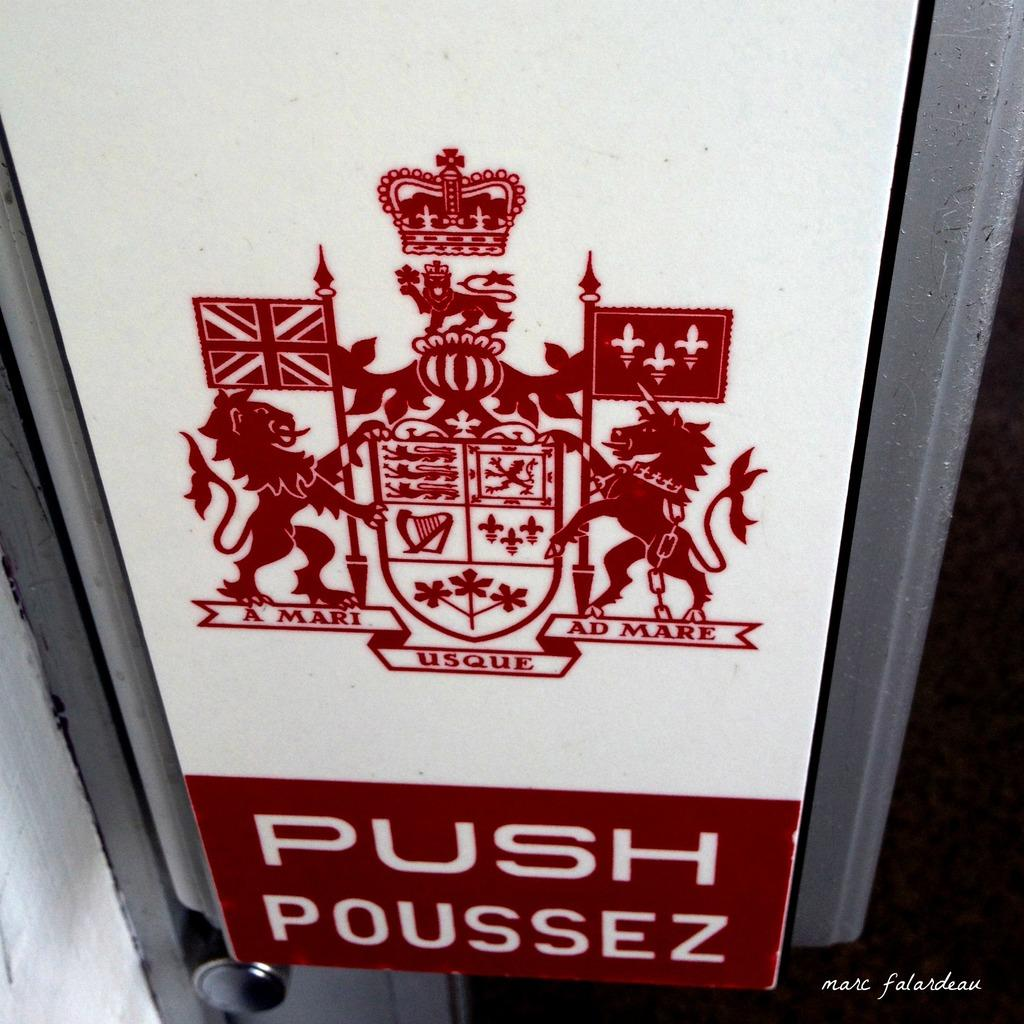Provide a one-sentence caption for the provided image. A sign with latin words A Mari Usque Ad Mare for a Push sign. 